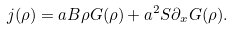Convert formula to latex. <formula><loc_0><loc_0><loc_500><loc_500>j ( \rho ) = a B \rho G ( \rho ) + a ^ { 2 } S \partial _ { x } G ( \rho ) .</formula> 